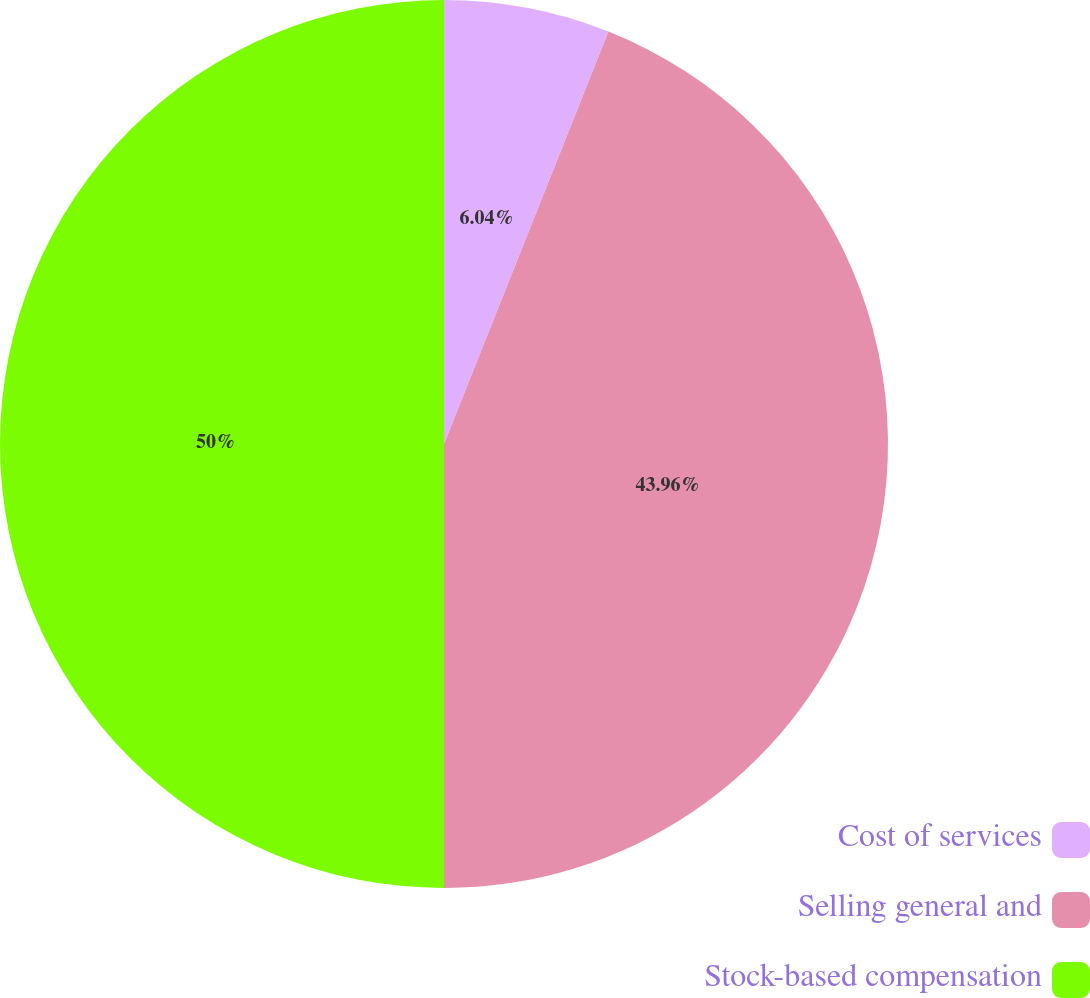Convert chart to OTSL. <chart><loc_0><loc_0><loc_500><loc_500><pie_chart><fcel>Cost of services<fcel>Selling general and<fcel>Stock-based compensation<nl><fcel>6.04%<fcel>43.96%<fcel>50.0%<nl></chart> 